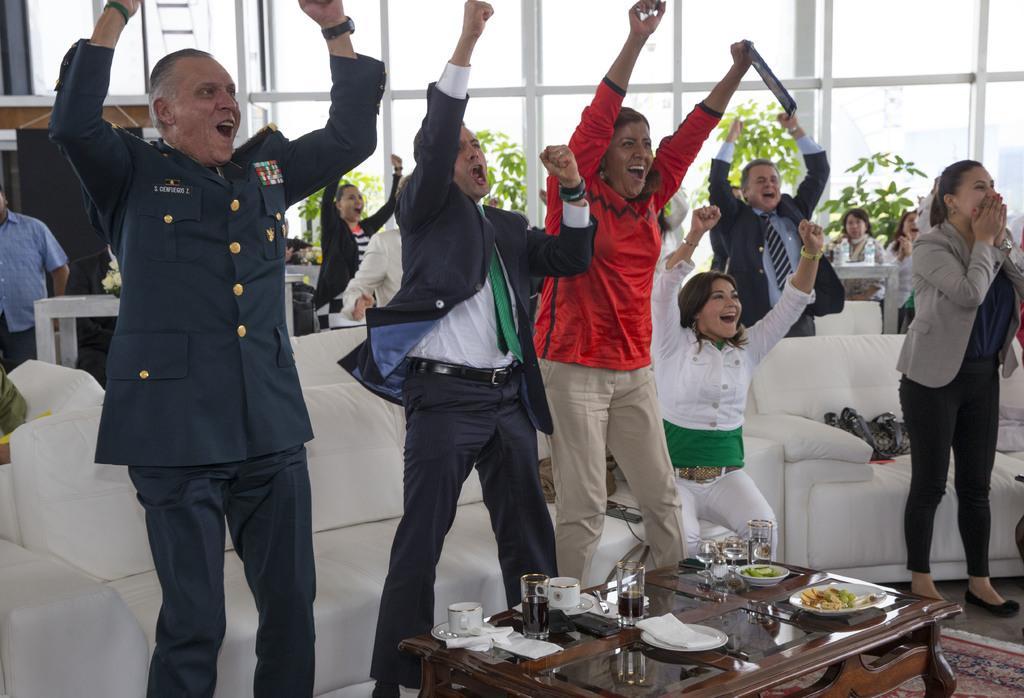Can you describe this image briefly? In this Picture we can see a group of men and women are enjoying keeping their hand up. On the right side we can see military soldier wearing black coat and batches on the right side is enjoying by shouting and putting his hand up. Beside we can see another man wearing black coat is also enjoying, beside a woman wearing red top is smiling and putting her hand up. Beside a girl sitting with white top is smiling. In front center table is placed on which some food , tissue papers , coke glass and tea cup are seen. 